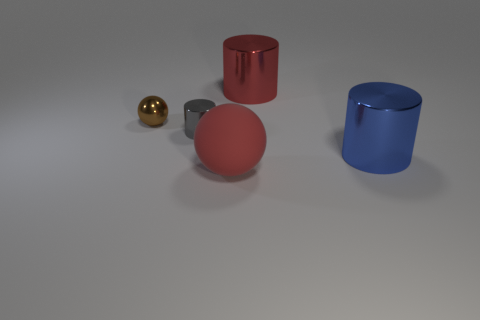Add 2 green cubes. How many objects exist? 7 Subtract all cylinders. How many objects are left? 2 Add 5 big rubber objects. How many big rubber objects exist? 6 Subtract 0 purple cubes. How many objects are left? 5 Subtract all small red metallic cylinders. Subtract all blue things. How many objects are left? 4 Add 4 brown metallic objects. How many brown metallic objects are left? 5 